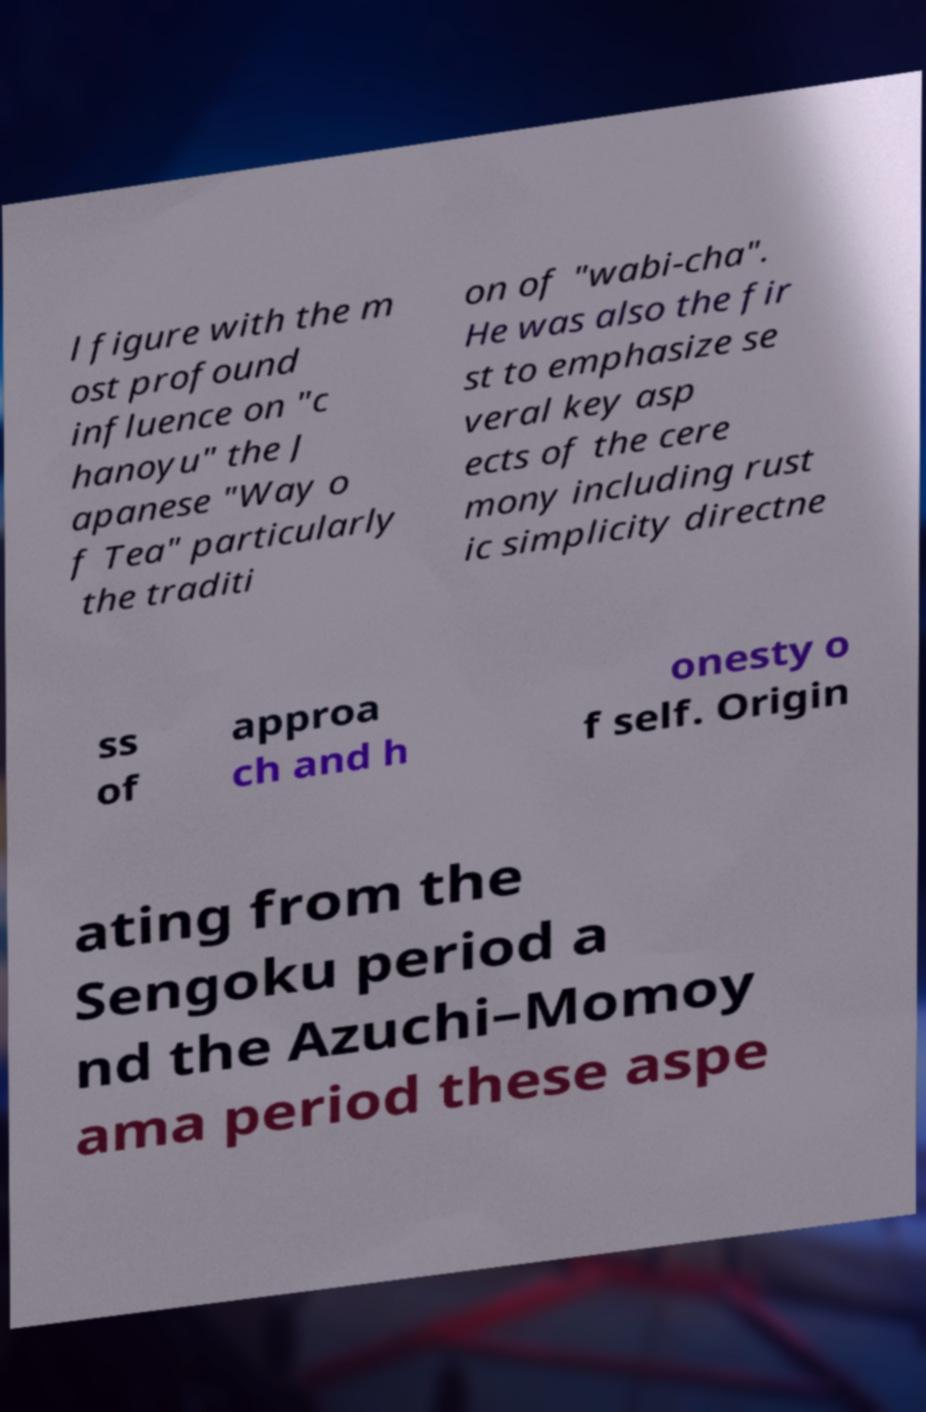For documentation purposes, I need the text within this image transcribed. Could you provide that? l figure with the m ost profound influence on "c hanoyu" the J apanese "Way o f Tea" particularly the traditi on of "wabi-cha". He was also the fir st to emphasize se veral key asp ects of the cere mony including rust ic simplicity directne ss of approa ch and h onesty o f self. Origin ating from the Sengoku period a nd the Azuchi–Momoy ama period these aspe 